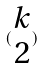<formula> <loc_0><loc_0><loc_500><loc_500>( \begin{matrix} k \\ 2 \end{matrix} )</formula> 